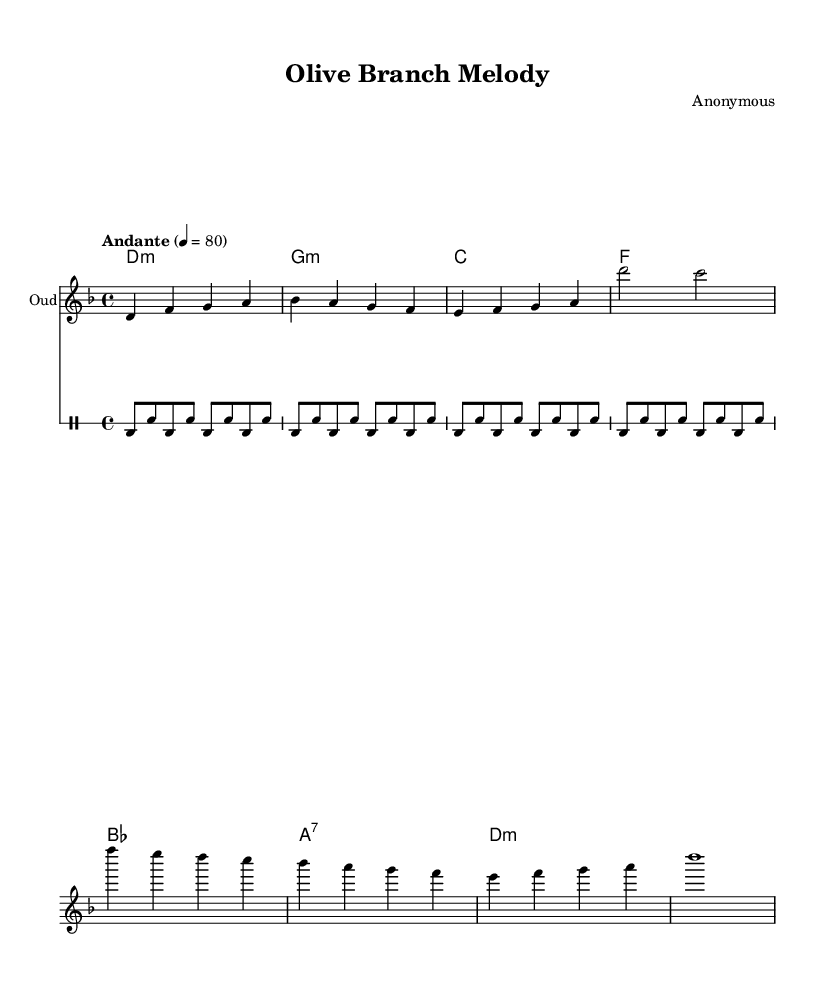What is the key signature of this music? The key signature is D minor, which has one flat (B♭) indicated at the beginning of the staff.
Answer: D minor What is the time signature of this piece? The time signature is 4/4, meaning there are four beats in a measure, and each beat is represented by a quarter note.
Answer: 4/4 What is the tempo marking for this piece? The tempo marking is "Andante," which suggests a moderate walking pace, and the specific metronome marking is 4 = 80.
Answer: Andante How many measures are in the chorus section? The chorus consists of four measures, as can be determined by counting the bars from the notation provided for the chorus lyrics.
Answer: 4 What instrument is indicated for the melody? The instrument specified for the melody is the "Oud," a traditional string instrument commonly used in Middle Eastern music.
Answer: Oud What theme does this piece explore? This piece explores themes of peace and reconciliation, as evident from the lyrics that focus on unity and healing in the context of conflict.
Answer: Peace and reconciliation What type of harmony is used throughout the piece? The harmony indicated aligns with modal chords, specifically representing minor and seventh chords, which are characteristic of traditional Middle Eastern music.
Answer: Modal chords 